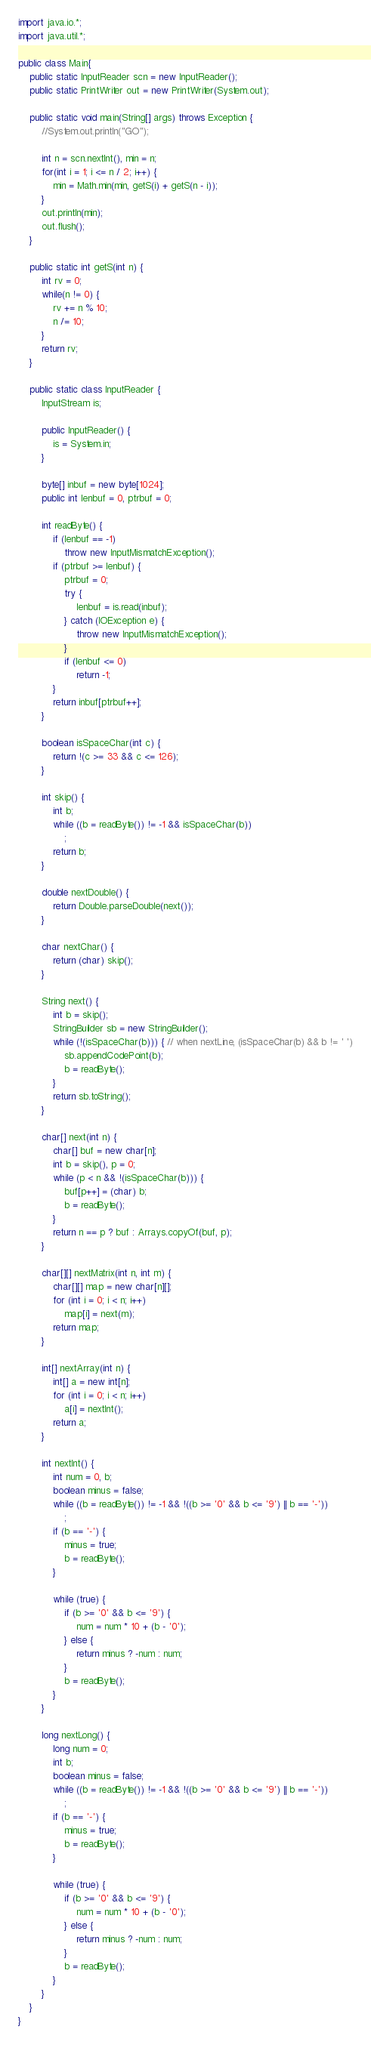<code> <loc_0><loc_0><loc_500><loc_500><_Java_>import java.io.*;
import java.util.*;

public class Main{
	public static InputReader scn = new InputReader();
	public static PrintWriter out = new PrintWriter(System.out);

	public static void main(String[] args) throws Exception {
		//System.out.println("GO");
		
		int n = scn.nextInt(), min = n;
		for(int i = 1; i <= n / 2; i++) {
			min = Math.min(min, getS(i) + getS(n - i));
		}
		out.println(min);
		out.flush();
	}

	public static int getS(int n) {
		int rv = 0;
		while(n != 0) {
			rv += n % 10;
			n /= 10;
		}
		return rv;
	}
	
	public static class InputReader {
		InputStream is;

		public InputReader() {
			is = System.in;
		}

		byte[] inbuf = new byte[1024];
		public int lenbuf = 0, ptrbuf = 0;

		int readByte() {
			if (lenbuf == -1)
				throw new InputMismatchException();
			if (ptrbuf >= lenbuf) {
				ptrbuf = 0;
				try {
					lenbuf = is.read(inbuf);
				} catch (IOException e) {
					throw new InputMismatchException();
				}
				if (lenbuf <= 0)
					return -1;
			}
			return inbuf[ptrbuf++];
		}

		boolean isSpaceChar(int c) {
			return !(c >= 33 && c <= 126);
		}

		int skip() {
			int b;
			while ((b = readByte()) != -1 && isSpaceChar(b))
				;
			return b;
		}

		double nextDouble() {
			return Double.parseDouble(next());
		}

		char nextChar() {
			return (char) skip();
		}

		String next() {
			int b = skip();
			StringBuilder sb = new StringBuilder();
			while (!(isSpaceChar(b))) { // when nextLine, (isSpaceChar(b) && b != ' ')
				sb.appendCodePoint(b);
				b = readByte();
			}
			return sb.toString();
		}

		char[] next(int n) {
			char[] buf = new char[n];
			int b = skip(), p = 0;
			while (p < n && !(isSpaceChar(b))) {
				buf[p++] = (char) b;
				b = readByte();
			}
			return n == p ? buf : Arrays.copyOf(buf, p);
		}

		char[][] nextMatrix(int n, int m) {
			char[][] map = new char[n][];
			for (int i = 0; i < n; i++)
				map[i] = next(m);
			return map;
		}

		int[] nextArray(int n) {
			int[] a = new int[n];
			for (int i = 0; i < n; i++)
				a[i] = nextInt();
			return a;
		}

		int nextInt() {
			int num = 0, b;
			boolean minus = false;
			while ((b = readByte()) != -1 && !((b >= '0' && b <= '9') || b == '-'))
				;
			if (b == '-') {
				minus = true;
				b = readByte();
			}

			while (true) {
				if (b >= '0' && b <= '9') {
					num = num * 10 + (b - '0');
				} else {
					return minus ? -num : num;
				}
				b = readByte();
			}
		}

		long nextLong() {
			long num = 0;
			int b;
			boolean minus = false;
			while ((b = readByte()) != -1 && !((b >= '0' && b <= '9') || b == '-'))
				;
			if (b == '-') {
				minus = true;
				b = readByte();
			}

			while (true) {
				if (b >= '0' && b <= '9') {
					num = num * 10 + (b - '0');
				} else {
					return minus ? -num : num;
				}
				b = readByte();
			}
		}
	}
}
</code> 